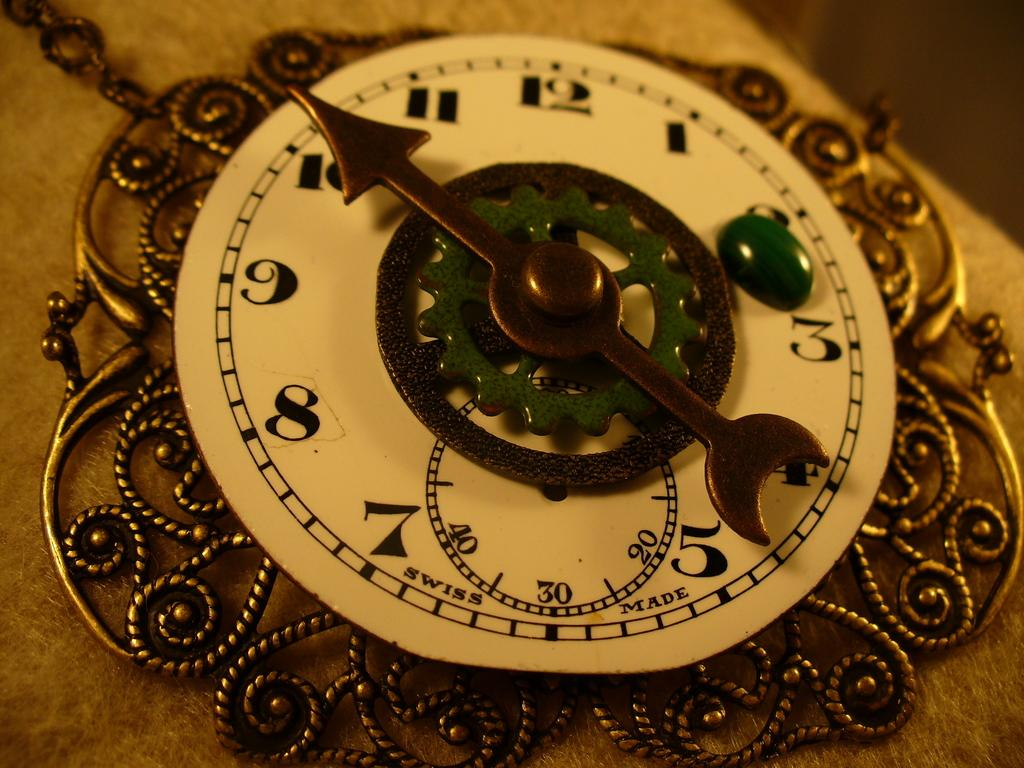<image>
Render a clear and concise summary of the photo. A clock is designated Swiss below the hands on the face. 